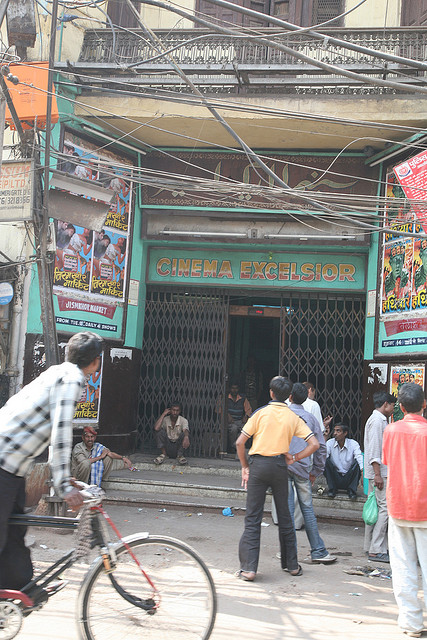What's the general mood or atmosphere of the scene? The general atmosphere of the image is one of daily urban life. The cinema, 'CINEMA EXCELSIOR', with its slightly worn-out appearance, evokes a sense of nostalgia and community presence. The people standing and conversing, along with the person riding a bicycle, add to the casual, busy ambiance. The overhead wires and posters contribute to the chaotic yet vibrant urban setting, painting a picture of a typical day in a lively city neighborhood. 